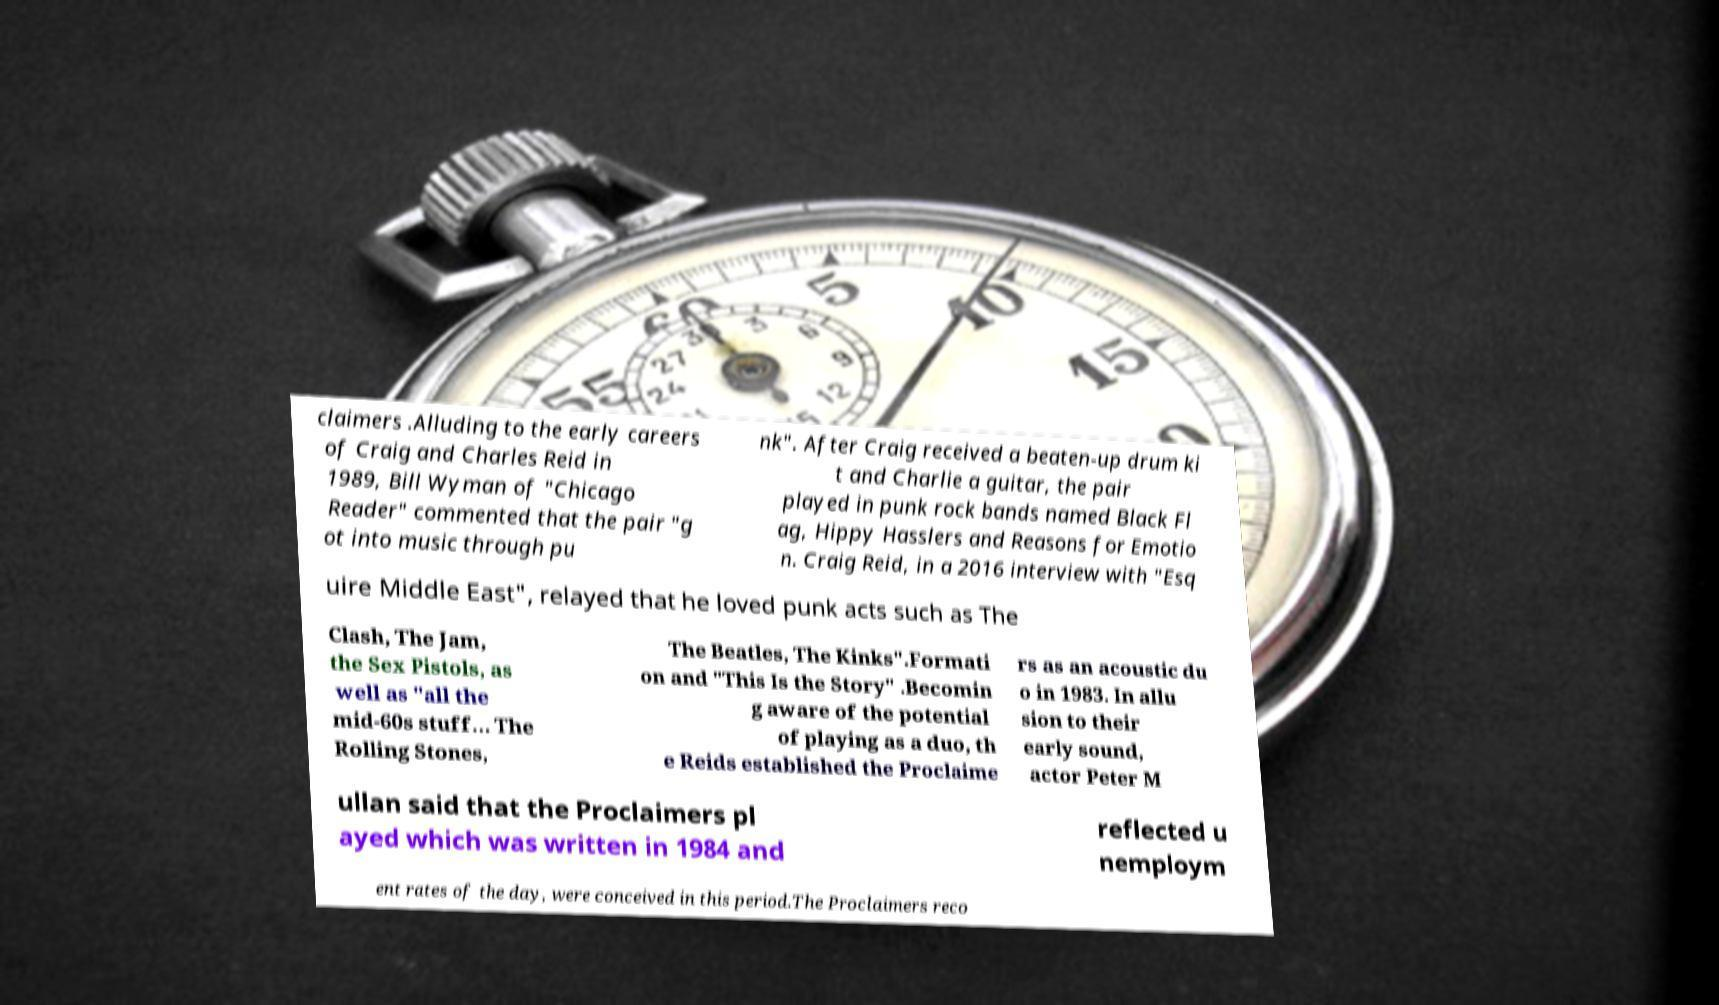For documentation purposes, I need the text within this image transcribed. Could you provide that? claimers .Alluding to the early careers of Craig and Charles Reid in 1989, Bill Wyman of "Chicago Reader" commented that the pair "g ot into music through pu nk". After Craig received a beaten-up drum ki t and Charlie a guitar, the pair played in punk rock bands named Black Fl ag, Hippy Hasslers and Reasons for Emotio n. Craig Reid, in a 2016 interview with "Esq uire Middle East", relayed that he loved punk acts such as The Clash, The Jam, the Sex Pistols, as well as "all the mid-60s stuff… The Rolling Stones, The Beatles, The Kinks".Formati on and "This Is the Story" .Becomin g aware of the potential of playing as a duo, th e Reids established the Proclaime rs as an acoustic du o in 1983. In allu sion to their early sound, actor Peter M ullan said that the Proclaimers pl ayed which was written in 1984 and reflected u nemploym ent rates of the day, were conceived in this period.The Proclaimers reco 